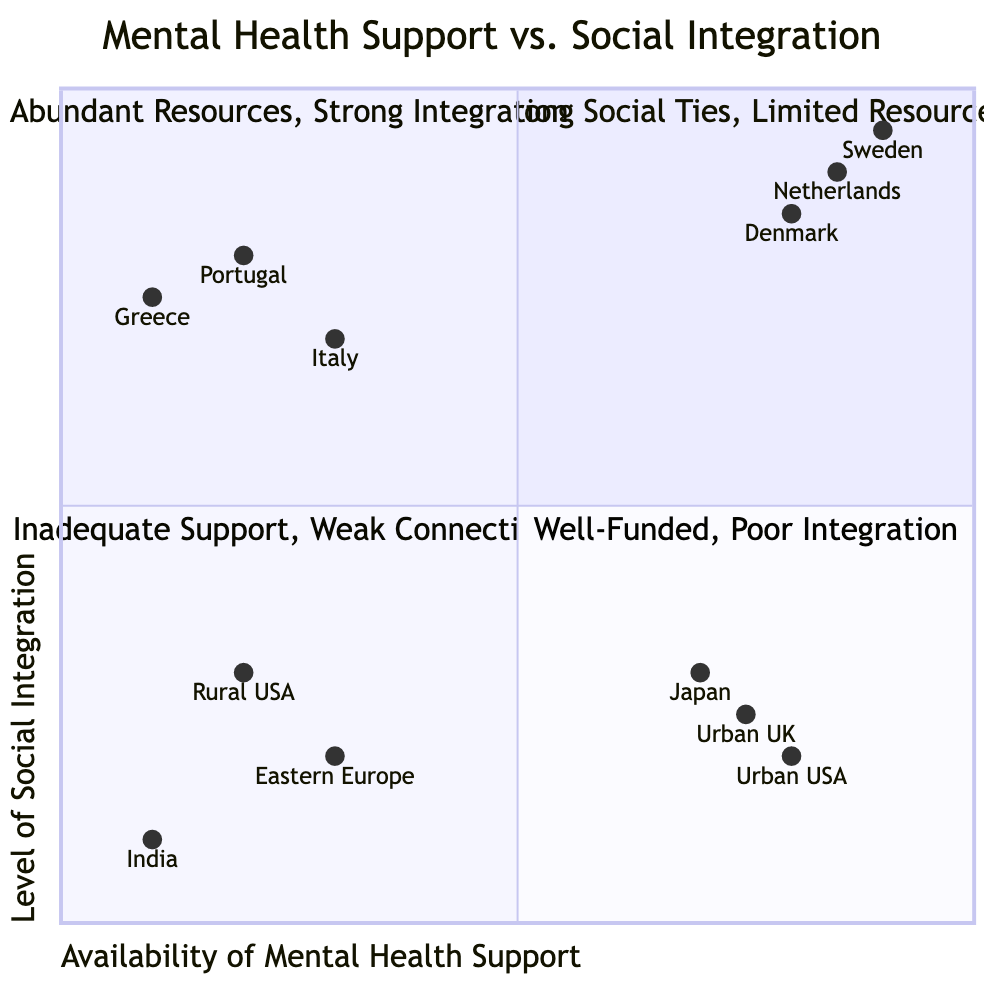What regions are located in the high support, high integration quadrant? The high support, high integration quadrant contains regions with abundant mental health resources and strong social ties. According to the data, these regions are Sweden, Netherlands, and Denmark.
Answer: Sweden, Netherlands, Denmark Which community has the lowest social integration score? The scores indicate that India, with a level of social integration at 0.1, has the lowest position in this chart. This is found in the low support, low integration quadrant.
Answer: India How many regions are in the low support, high integration quadrant? In the low support, high integration quadrant, three regions are identified: Italy, Portugal, and Greece. This is confirmed by checking the data provided.
Answer: 3 What does the high support, low integration quadrant indicate about its regions? The high support, low integration quadrant describes areas that possess considerable mental health resources but experience poor social integration. The regions described here include urban areas in Japan, certain cities in the USA, and urban United Kingdom.
Answer: Well-funded, poor integration Which region is an example of low support and low integration? The low support and low integration quadrant features regions with both inadequate mental health resources and weak social connections. Rural areas in the USA is a specific example provided in the data.
Answer: Rural USA What characteristics are common among regions in the high support, high integration quadrant? Key attributes of regions in this quadrant include accessible mental health services, community support programs, high employment rates, and strong social safety nets. This information is depicted in the key attributes of the quadrant.
Answer: Accessible mental health services How does cultural stigma influence social integration in the low support, high integration quadrant? The presence of cultural stigma surrounding mental health in the low support, high integration quadrant may make individuals less likely to seek help despite strong community ties. This can affect mental health outcomes while still fostering social integration.
Answer: Cultural stigma around mental health What is the relationship between mental health support and social integration for urban UK? Urban United Kingdom demonstrates high mental health support availability but low social integration, placing it in the high support, low integration quadrant. This exemplifies the dichotomy where resources don't translate into community connectivity.
Answer: High support, low integration 